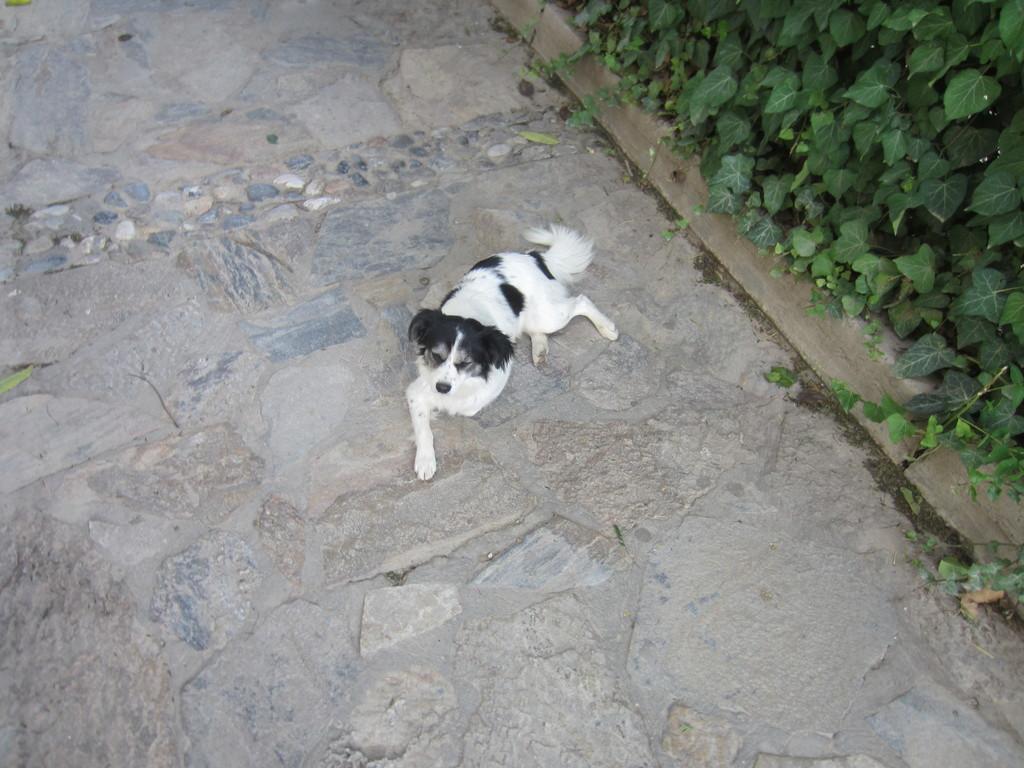Can you describe this image briefly? In this picture we can see a dog on the ground and in the background we can see trees. 